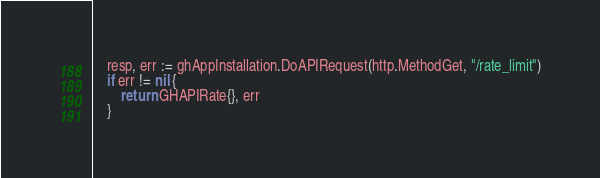Convert code to text. <code><loc_0><loc_0><loc_500><loc_500><_Go_>	resp, err := ghAppInstallation.DoAPIRequest(http.MethodGet, "/rate_limit")
	if err != nil {
		return GHAPIRate{}, err
	}</code> 